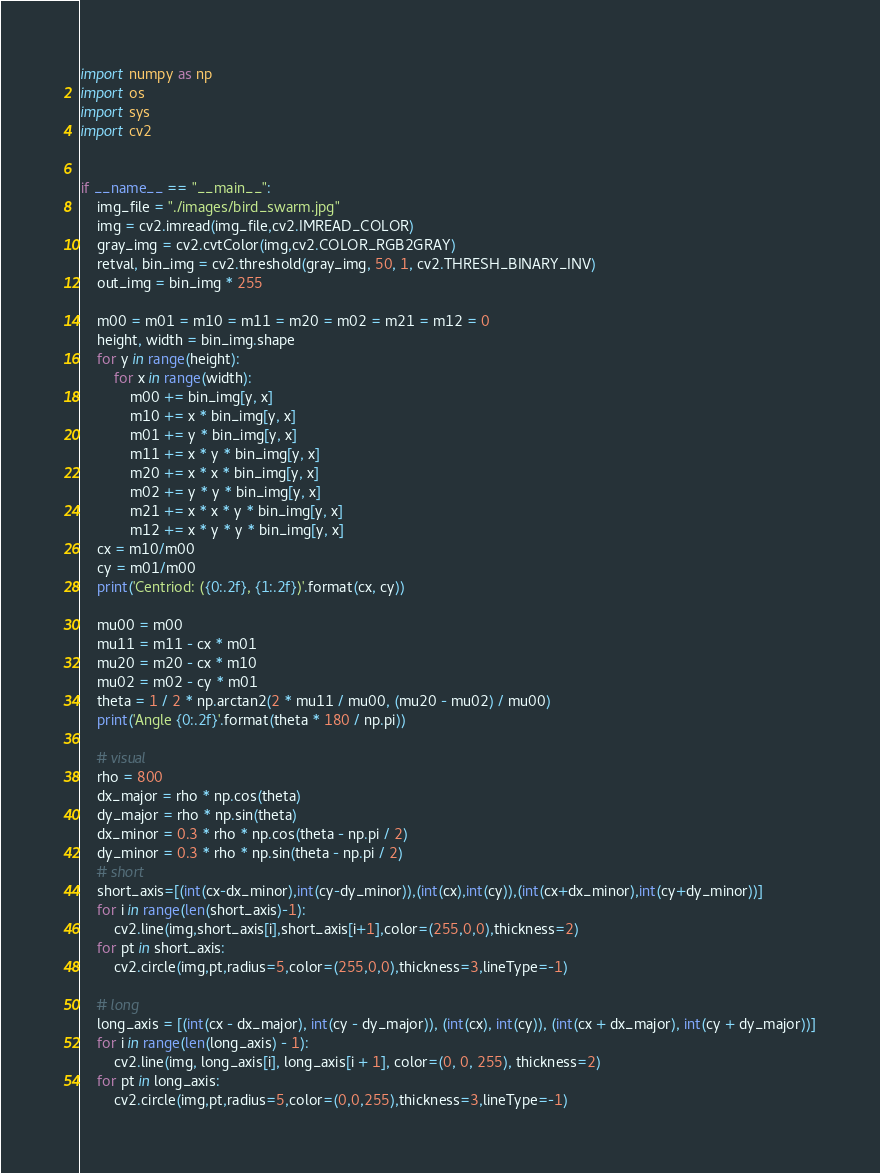<code> <loc_0><loc_0><loc_500><loc_500><_Python_>import numpy as np
import os
import sys
import cv2


if __name__ == "__main__":
    img_file = "./images/bird_swarm.jpg"
    img = cv2.imread(img_file,cv2.IMREAD_COLOR)
    gray_img = cv2.cvtColor(img,cv2.COLOR_RGB2GRAY)
    retval, bin_img = cv2.threshold(gray_img, 50, 1, cv2.THRESH_BINARY_INV)
    out_img = bin_img * 255

    m00 = m01 = m10 = m11 = m20 = m02 = m21 = m12 = 0
    height, width = bin_img.shape
    for y in range(height):
        for x in range(width):
            m00 += bin_img[y, x]
            m10 += x * bin_img[y, x]
            m01 += y * bin_img[y, x]
            m11 += x * y * bin_img[y, x]
            m20 += x * x * bin_img[y, x]
            m02 += y * y * bin_img[y, x]
            m21 += x * x * y * bin_img[y, x]
            m12 += x * y * y * bin_img[y, x]
    cx = m10/m00
    cy = m01/m00
    print('Centriod: ({0:.2f}, {1:.2f})'.format(cx, cy))

    mu00 = m00
    mu11 = m11 - cx * m01
    mu20 = m20 - cx * m10
    mu02 = m02 - cy * m01
    theta = 1 / 2 * np.arctan2(2 * mu11 / mu00, (mu20 - mu02) / mu00)
    print('Angle {0:.2f}'.format(theta * 180 / np.pi))

    # visual
    rho = 800
    dx_major = rho * np.cos(theta)
    dy_major = rho * np.sin(theta)
    dx_minor = 0.3 * rho * np.cos(theta - np.pi / 2)
    dy_minor = 0.3 * rho * np.sin(theta - np.pi / 2)
    # short
    short_axis=[(int(cx-dx_minor),int(cy-dy_minor)),(int(cx),int(cy)),(int(cx+dx_minor),int(cy+dy_minor))]
    for i in range(len(short_axis)-1):
        cv2.line(img,short_axis[i],short_axis[i+1],color=(255,0,0),thickness=2)
    for pt in short_axis:
        cv2.circle(img,pt,radius=5,color=(255,0,0),thickness=3,lineType=-1)

    # long
    long_axis = [(int(cx - dx_major), int(cy - dy_major)), (int(cx), int(cy)), (int(cx + dx_major), int(cy + dy_major))]
    for i in range(len(long_axis) - 1):
        cv2.line(img, long_axis[i], long_axis[i + 1], color=(0, 0, 255), thickness=2)
    for pt in long_axis:
        cv2.circle(img,pt,radius=5,color=(0,0,255),thickness=3,lineType=-1)
</code> 